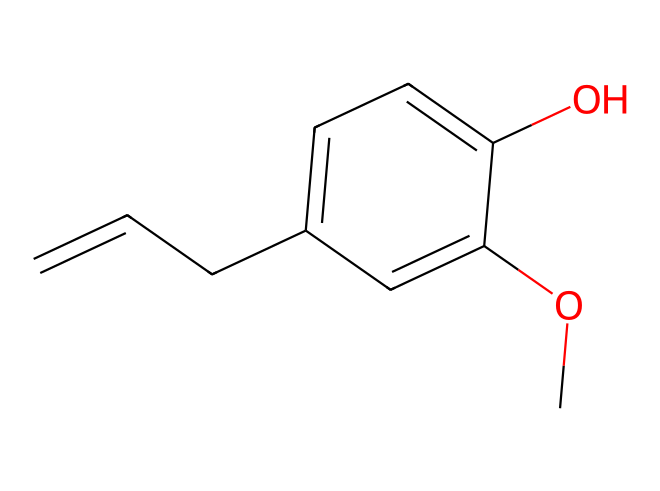How many rings are present in eugenol's structure? The chemical structure shows a single aromatic ring, which is characteristic of phenols. The benzene part is evident, indicating one ring.
Answer: one ring What functional groups are present in eugenol? Observing the structure, we can identify a hydroxyl group (-OH) and a methoxy group (-OCH3) as the key functional groups in eugenol's molecular framework.
Answer: hydroxyl and methoxy What is the primary aromatic compound in eugenol? The core structure of eugenol includes a benzene ring, which is the primary aromatic compound in this molecule.
Answer: benzene How many carbon atoms are there in eugenol? By counting the carbon atoms in the structure, we find a total of ten carbon atoms forming various parts of the molecule, including the alkene and aromatic structures.
Answer: ten What property of eugenol contributes to its flavor profile? The presence of both the aromatic and hydroxyl functional group in eugenol enhances its flavor, contributing to the characteristic clove oil taste and aroma.
Answer: flavor compound How does the presence of the methoxy group affect eugenol? The methoxy group provides electron-donating characteristics to the benzene ring, affecting its reactivity and potentially enhancing its aromatic properties in comparison to simpler phenolic compounds.
Answer: enhances reactivity 